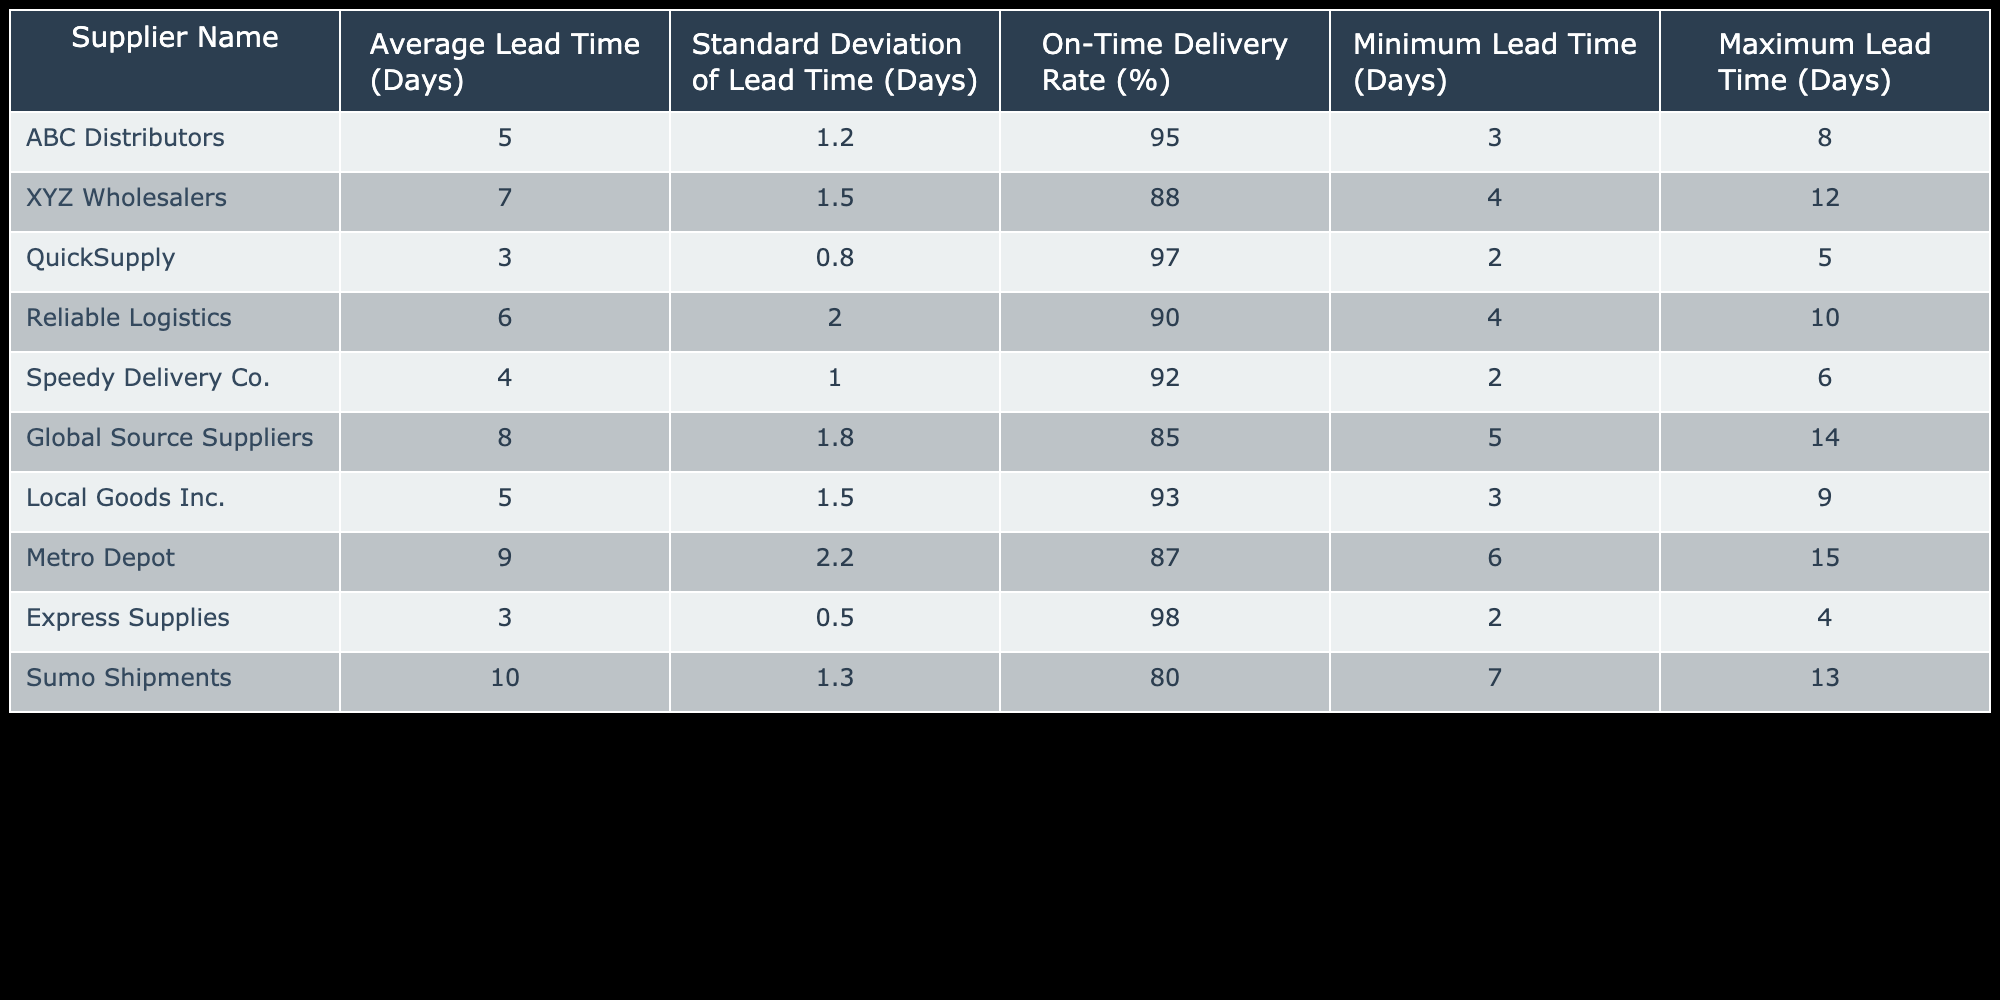What is the average lead time for QuickSupply? QuickSupply has an "Average Lead Time" of 3 days as stated directly in the table.
Answer: 3 days Which supplier has the highest on-time delivery rate? The table lists the "On-Time Delivery Rate (%)" of all suppliers, with Express Supplies having an 98% rate, making it the highest.
Answer: Express Supplies What is the difference in average lead time between Global Source Suppliers and Speedy Delivery Co.? Global Source Suppliers has an average lead time of 8 days while Speedy Delivery Co. has an average lead time of 4 days. The difference is 8 - 4 = 4 days.
Answer: 4 days Is the minimum lead time for XYZ Wholesalers less than that of Reliable Logistics? The table shows that the minimum lead time for XYZ Wholesalers is 4 days and for Reliable Logistics is 4 days as well. Since both are equal, the statement is false.
Answer: No What is the average standard deviation of lead times across all suppliers? By looking at the "Standard Deviation of Lead Time (Days)" column, we can add each standard deviation (1.2 + 1.5 + 0.8 + 2.0 + 1.0 + 1.8 + 1.5 + 2.2 + 0.5 + 1.3 = 12.3) and divide by the number of suppliers (10), giving an average of 12.3 / 10 = 1.23 days.
Answer: 1.23 days Which supplier has the maximum lead time? According to the "Maximum Lead Time (Days)" column, Sumo Shipments has the highest maximum lead time of 13 days.
Answer: Sumo Shipments Do any suppliers have an on-time delivery rate above 95%? By checking the "On-Time Delivery Rate (%)" column, we identify that ABC Distributors, QuickSupply, and Express Supplies all exceed 95%. Therefore, there are suppliers that meet this criterion.
Answer: Yes What is the range of average lead times across all suppliers? The "Average Lead Time (Days)" column shows a maximum of 10 days (by Sumo Shipments) and a minimum of 3 days (by QuickSupply). The range is calculated as 10 - 3 = 7 days.
Answer: 7 days 